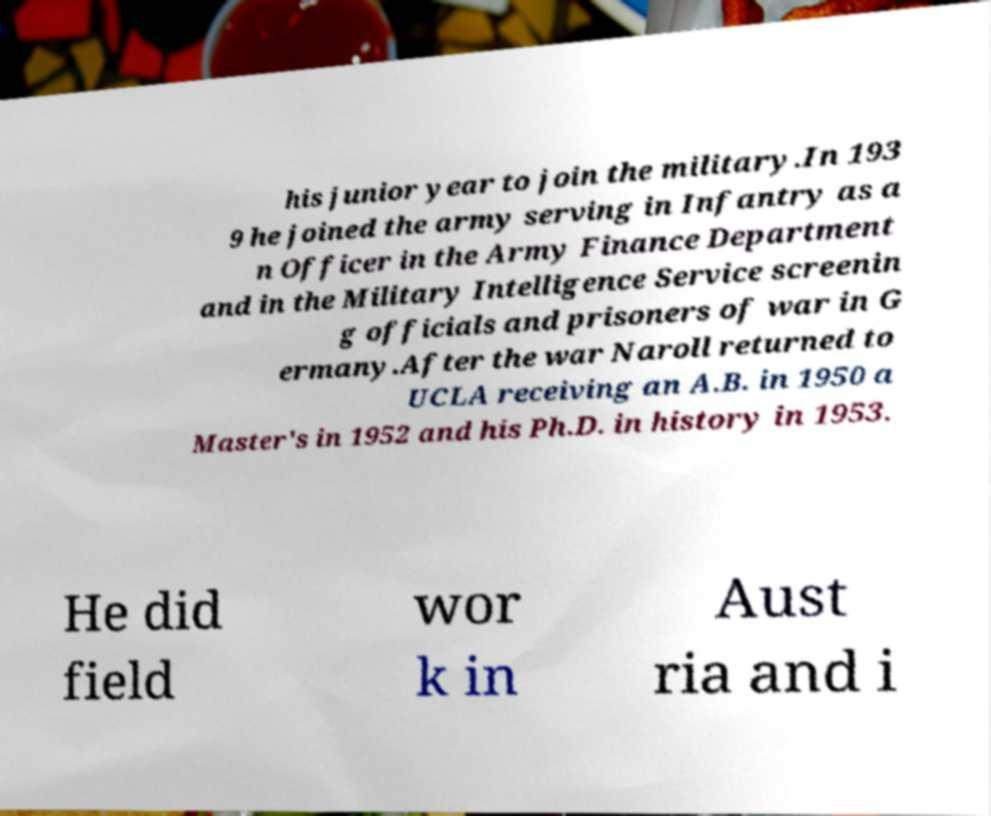There's text embedded in this image that I need extracted. Can you transcribe it verbatim? his junior year to join the military.In 193 9 he joined the army serving in Infantry as a n Officer in the Army Finance Department and in the Military Intelligence Service screenin g officials and prisoners of war in G ermany.After the war Naroll returned to UCLA receiving an A.B. in 1950 a Master's in 1952 and his Ph.D. in history in 1953. He did field wor k in Aust ria and i 